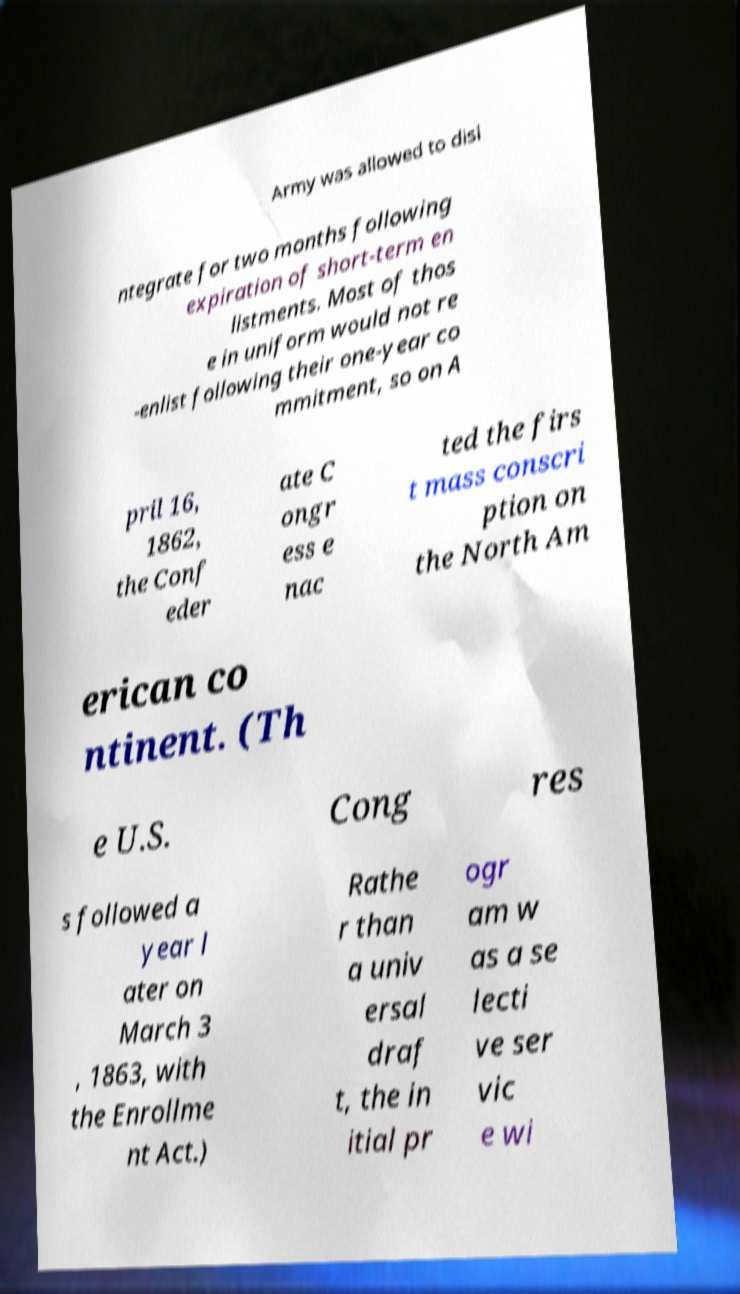Can you accurately transcribe the text from the provided image for me? Army was allowed to disi ntegrate for two months following expiration of short-term en listments. Most of thos e in uniform would not re -enlist following their one-year co mmitment, so on A pril 16, 1862, the Conf eder ate C ongr ess e nac ted the firs t mass conscri ption on the North Am erican co ntinent. (Th e U.S. Cong res s followed a year l ater on March 3 , 1863, with the Enrollme nt Act.) Rathe r than a univ ersal draf t, the in itial pr ogr am w as a se lecti ve ser vic e wi 